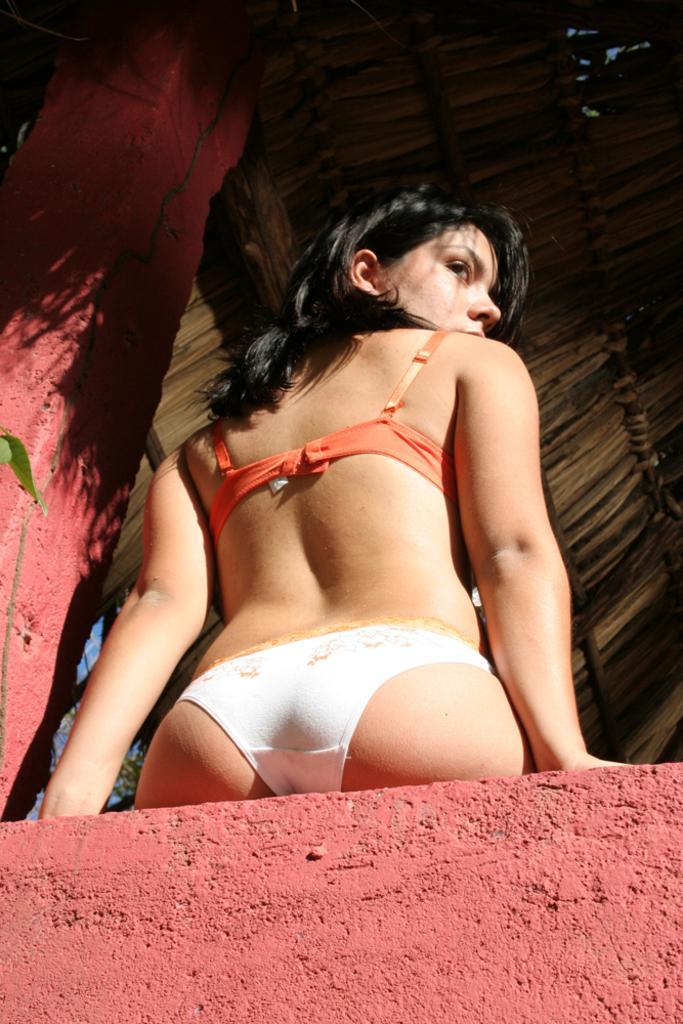Please provide a concise description of this image. In this image there is a woman, pillar, wall and a hut. 